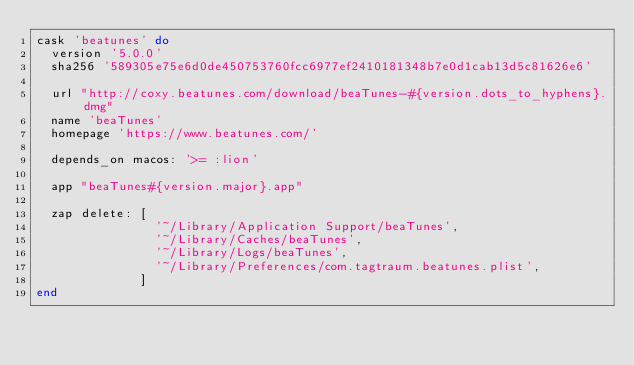<code> <loc_0><loc_0><loc_500><loc_500><_Ruby_>cask 'beatunes' do
  version '5.0.0'
  sha256 '589305e75e6d0de450753760fcc6977ef2410181348b7e0d1cab13d5c81626e6'

  url "http://coxy.beatunes.com/download/beaTunes-#{version.dots_to_hyphens}.dmg"
  name 'beaTunes'
  homepage 'https://www.beatunes.com/'

  depends_on macos: '>= :lion'

  app "beaTunes#{version.major}.app"

  zap delete: [
                '~/Library/Application Support/beaTunes',
                '~/Library/Caches/beaTunes',
                '~/Library/Logs/beaTunes',
                '~/Library/Preferences/com.tagtraum.beatunes.plist',
              ]
end
</code> 